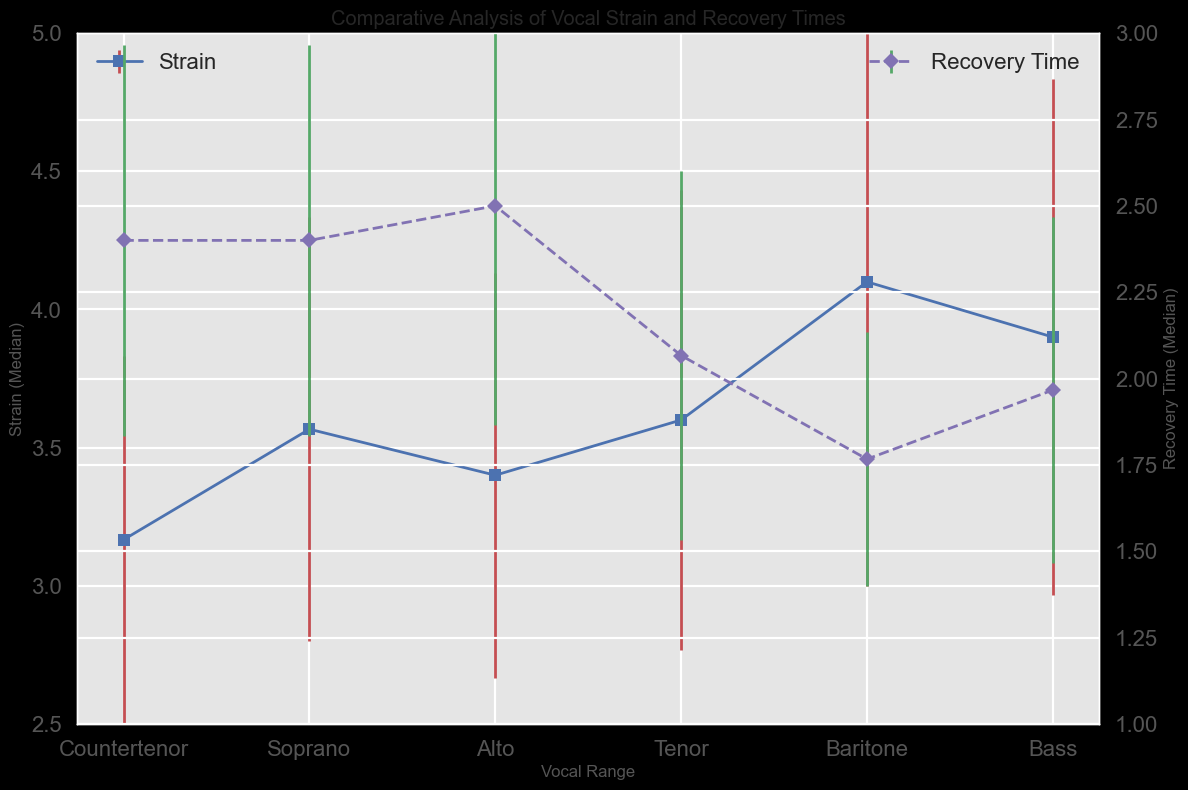Which vocal range has the highest median strain? Look at the highest data point in the blue markers. Sopranos have the highest median strain value.
Answer: Soprano Which vocal range has the lowest median recovery time? Observe the lowest data point in the pink markers. Sopranos have the lowest median recovery time value.
Answer: Soprano How does the median strain of countertenors compare to basses? Compare the height of the blue markers for both vocal ranges. Countertenors have higher median strain than basses.
Answer: Countertenors have higher strain What is the difference in median recovery time between Altos and Tenors? Check the vertical distance between the pink markers for Altos and Tenors. Alto median recovery time is approximately 2.4, and Tenor median recovery time is 2.0. The difference is (2.4 - 2.0).
Answer: 0.4 Out of all vocal ranges, which one has the smallest standard deviation in strain? Look at the error bars on the blue markers, focusing on their horizontal size. Altos have the smallest error bar in strain indicating the smallest deviation.
Answer: Alto Which vocal range has the highest variation in recovery time? Observe the horizontal extent of the error bars for the pink markers. Basses have the longest error bars in recovery time, indicating the highest variation.
Answer: Bass How does the standard deviation of strain for Baritones compare to the standard deviation of recovery time for Baritones? Look at the horizontal size of the error bars for Baritones in both blue markers (strain) and pink markers (recovery time). Both have similar error bars indicating similar standard deviations.
Answer: Similar For Tenors, what is the average of the median strain and median recovery time? Find the median values for Tenors in both the blue and pink markers. Strain is about 3.9, and recovery time is about 2.0. The average is (3.9 + 2.0) / 2.
Answer: 2.95 Compare the standard deviation of strain across Tenors and Basses. Are they the same? Evaluate the horizontal size of error bars in the blue markers for Tenors and Basses. Both have roughly the same error bars indicating similar standard deviations.
Answer: Yes, they are the same 